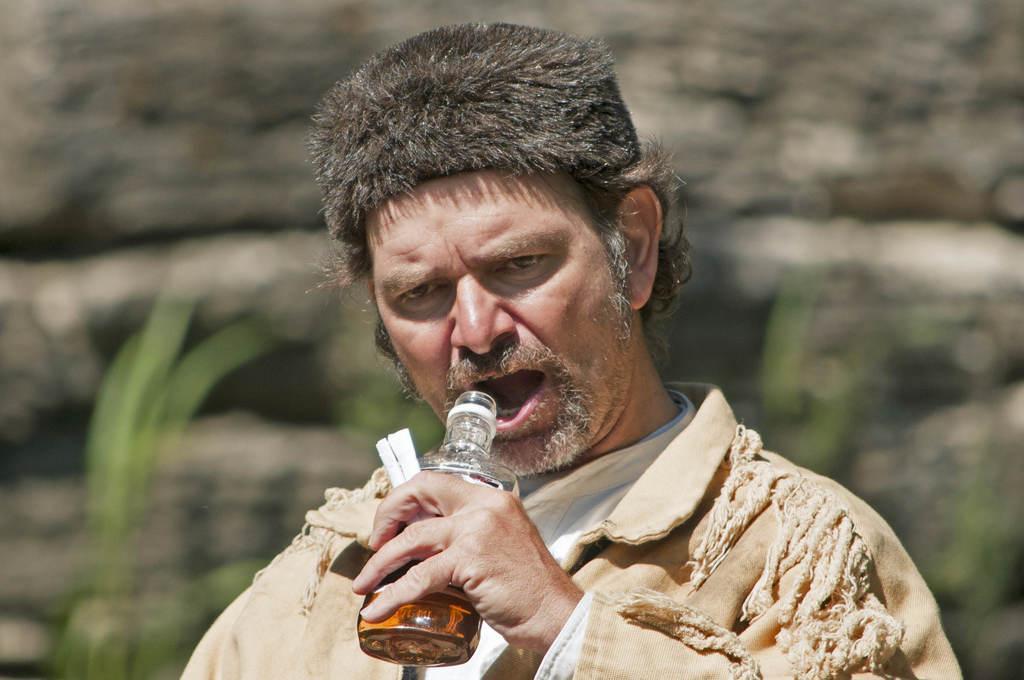Can you describe this image briefly? In this picture there is a man standing and holding the bottle. At the back there are plants and there is a rock. 